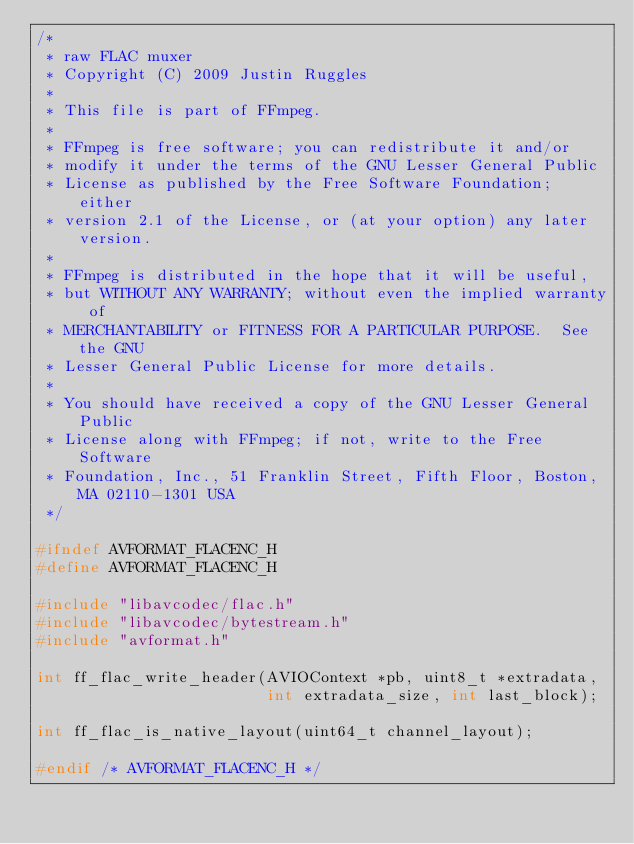<code> <loc_0><loc_0><loc_500><loc_500><_C_>/*
 * raw FLAC muxer
 * Copyright (C) 2009 Justin Ruggles
 *
 * This file is part of FFmpeg.
 *
 * FFmpeg is free software; you can redistribute it and/or
 * modify it under the terms of the GNU Lesser General Public
 * License as published by the Free Software Foundation; either
 * version 2.1 of the License, or (at your option) any later version.
 *
 * FFmpeg is distributed in the hope that it will be useful,
 * but WITHOUT ANY WARRANTY; without even the implied warranty of
 * MERCHANTABILITY or FITNESS FOR A PARTICULAR PURPOSE.  See the GNU
 * Lesser General Public License for more details.
 *
 * You should have received a copy of the GNU Lesser General Public
 * License along with FFmpeg; if not, write to the Free Software
 * Foundation, Inc., 51 Franklin Street, Fifth Floor, Boston, MA 02110-1301 USA
 */

#ifndef AVFORMAT_FLACENC_H
#define AVFORMAT_FLACENC_H

#include "libavcodec/flac.h"
#include "libavcodec/bytestream.h"
#include "avformat.h"

int ff_flac_write_header(AVIOContext *pb, uint8_t *extradata,
                         int extradata_size, int last_block);

int ff_flac_is_native_layout(uint64_t channel_layout);

#endif /* AVFORMAT_FLACENC_H */
</code> 